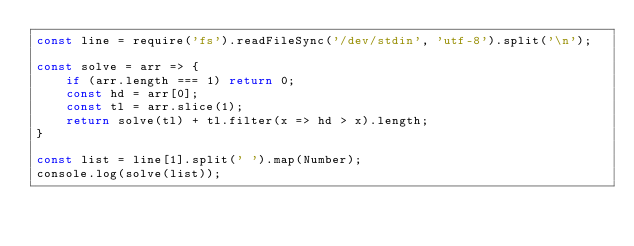<code> <loc_0><loc_0><loc_500><loc_500><_JavaScript_>const line = require('fs').readFileSync('/dev/stdin', 'utf-8').split('\n');

const solve = arr => {
    if (arr.length === 1) return 0;
    const hd = arr[0];
    const tl = arr.slice(1);
    return solve(tl) + tl.filter(x => hd > x).length;
}

const list = line[1].split(' ').map(Number);
console.log(solve(list));

</code> 